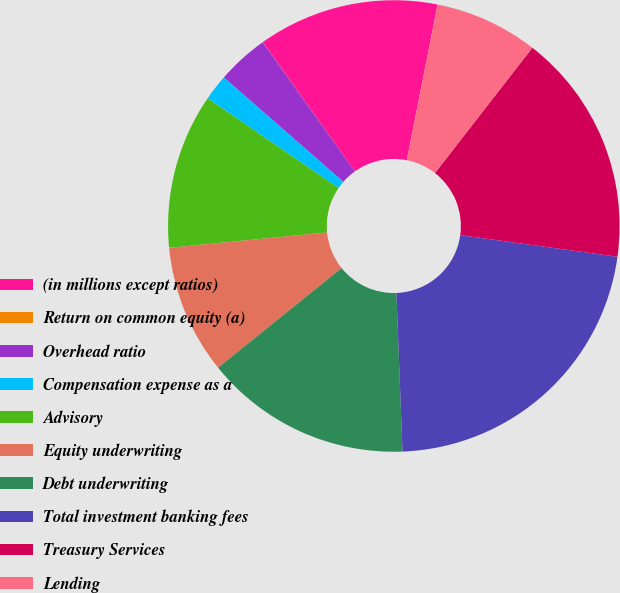Convert chart. <chart><loc_0><loc_0><loc_500><loc_500><pie_chart><fcel>(in millions except ratios)<fcel>Return on common equity (a)<fcel>Overhead ratio<fcel>Compensation expense as a<fcel>Advisory<fcel>Equity underwriting<fcel>Debt underwriting<fcel>Total investment banking fees<fcel>Treasury Services<fcel>Lending<nl><fcel>12.96%<fcel>0.01%<fcel>3.71%<fcel>1.86%<fcel>11.11%<fcel>9.26%<fcel>14.81%<fcel>22.21%<fcel>16.66%<fcel>7.41%<nl></chart> 